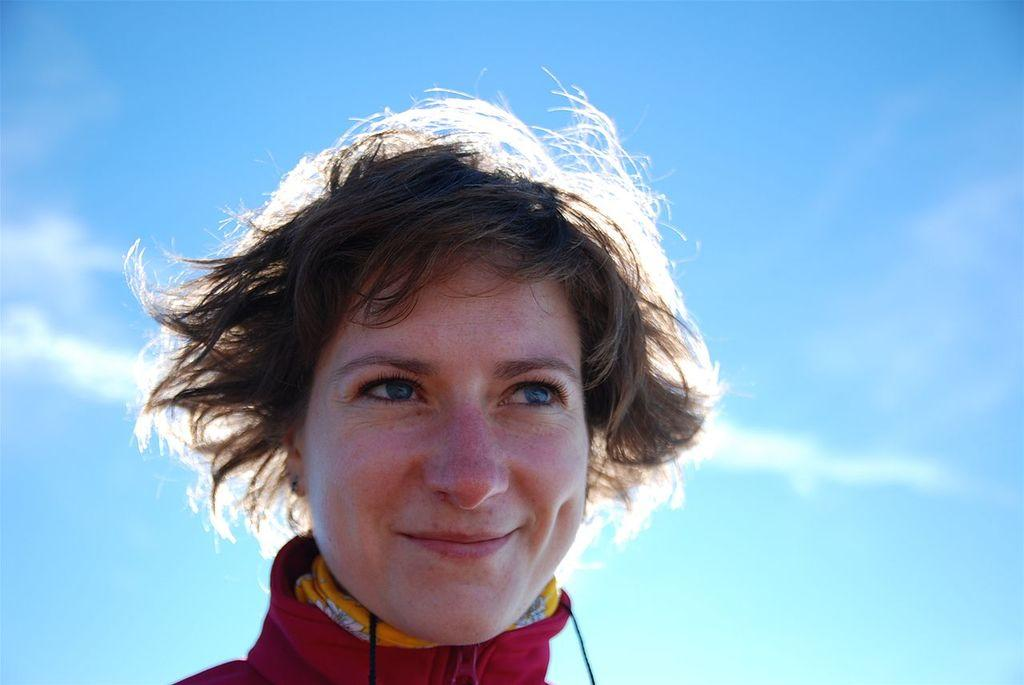What is present in the image? There is a person in the image. How is the person's expression in the image? The person is smiling. What can be seen in the background of the image? The sky is visible in the background of the image. What type of scarf is the person wearing in the image? There is no scarf visible in the image. Can you describe how the person is touching the basin in the image? There is no basin present in the image, so it is not possible to describe any interaction with it. 